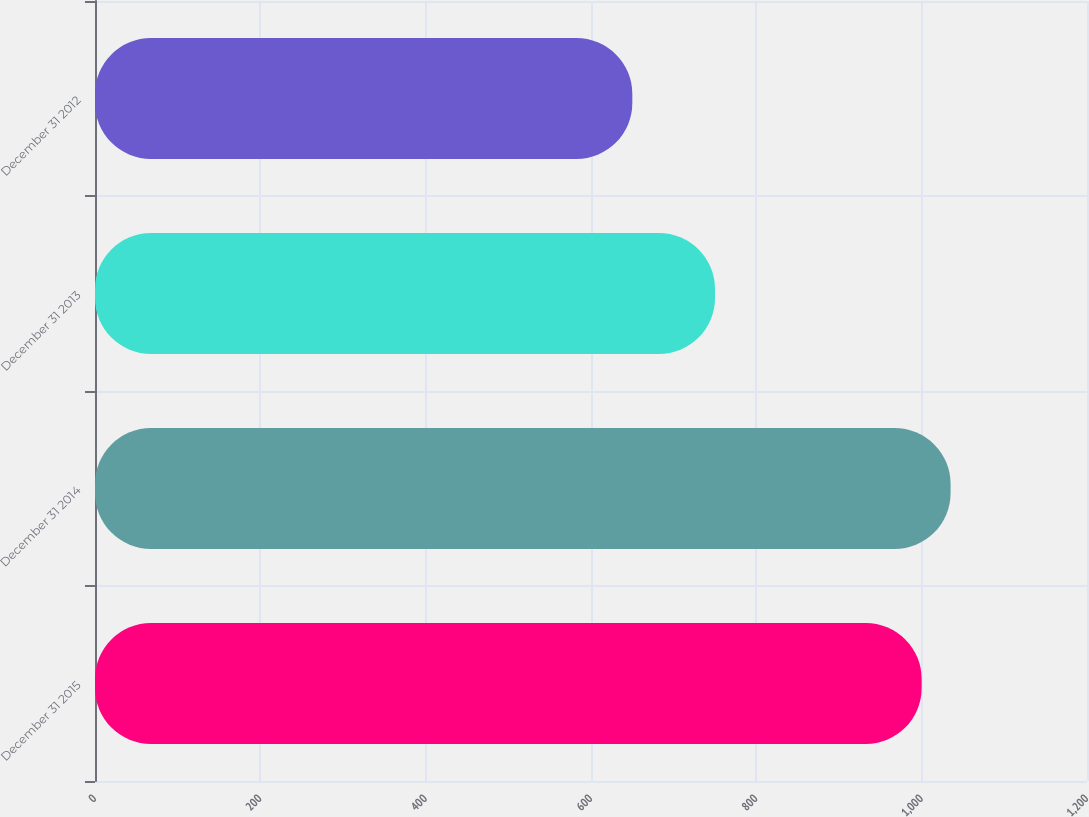Convert chart. <chart><loc_0><loc_0><loc_500><loc_500><bar_chart><fcel>December 31 2015<fcel>December 31 2014<fcel>December 31 2013<fcel>December 31 2012<nl><fcel>1000<fcel>1035<fcel>750<fcel>650<nl></chart> 